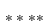Convert formula to latex. <formula><loc_0><loc_0><loc_500><loc_500>* * * *</formula> 